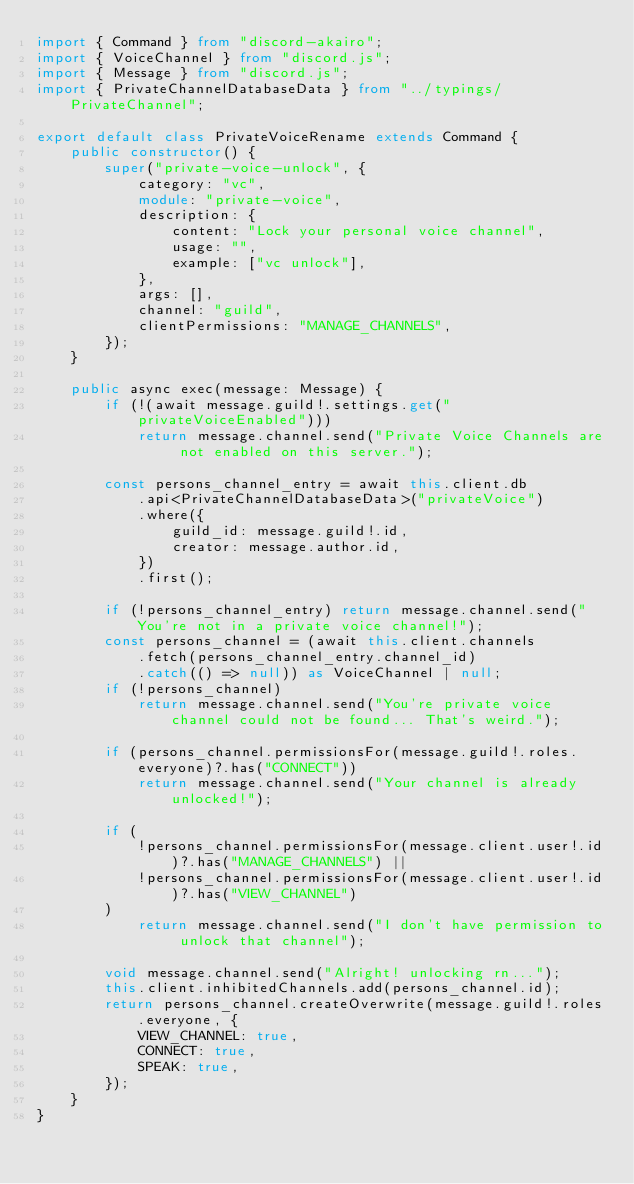<code> <loc_0><loc_0><loc_500><loc_500><_TypeScript_>import { Command } from "discord-akairo";
import { VoiceChannel } from "discord.js";
import { Message } from "discord.js";
import { PrivateChannelDatabaseData } from "../typings/PrivateChannel";

export default class PrivateVoiceRename extends Command {
    public constructor() {
        super("private-voice-unlock", {
            category: "vc",
            module: "private-voice",
            description: {
                content: "Lock your personal voice channel",
                usage: "",
                example: ["vc unlock"],
            },
            args: [],
            channel: "guild",
            clientPermissions: "MANAGE_CHANNELS",
        });
    }

    public async exec(message: Message) {
        if (!(await message.guild!.settings.get("privateVoiceEnabled")))
            return message.channel.send("Private Voice Channels are not enabled on this server.");

        const persons_channel_entry = await this.client.db
            .api<PrivateChannelDatabaseData>("privateVoice")
            .where({
                guild_id: message.guild!.id,
                creator: message.author.id,
            })
            .first();

        if (!persons_channel_entry) return message.channel.send("You're not in a private voice channel!");
        const persons_channel = (await this.client.channels
            .fetch(persons_channel_entry.channel_id)
            .catch(() => null)) as VoiceChannel | null;
        if (!persons_channel)
            return message.channel.send("You're private voice channel could not be found... That's weird.");

        if (persons_channel.permissionsFor(message.guild!.roles.everyone)?.has("CONNECT"))
            return message.channel.send("Your channel is already unlocked!");

        if (
            !persons_channel.permissionsFor(message.client.user!.id)?.has("MANAGE_CHANNELS") ||
            !persons_channel.permissionsFor(message.client.user!.id)?.has("VIEW_CHANNEL")
        )
            return message.channel.send("I don't have permission to unlock that channel");

        void message.channel.send("Alright! unlocking rn...");
        this.client.inhibitedChannels.add(persons_channel.id);
        return persons_channel.createOverwrite(message.guild!.roles.everyone, {
            VIEW_CHANNEL: true,
            CONNECT: true,
            SPEAK: true,
        });
    }
}
</code> 